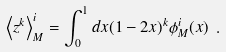<formula> <loc_0><loc_0><loc_500><loc_500>\left \langle z ^ { k } \right \rangle _ { M } ^ { i } = \int _ { 0 } ^ { 1 } d x ( 1 - 2 x ) ^ { k } \phi _ { M } ^ { i } ( x ) \ .</formula> 